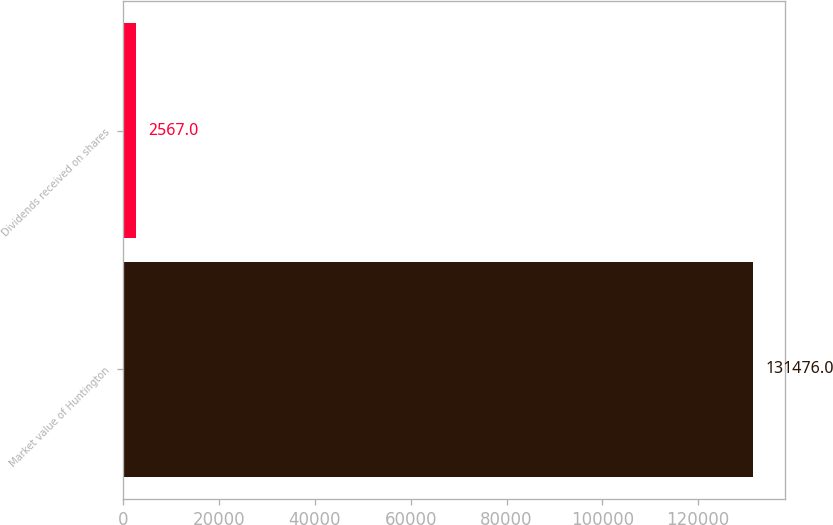Convert chart. <chart><loc_0><loc_0><loc_500><loc_500><bar_chart><fcel>Market value of Huntington<fcel>Dividends received on shares<nl><fcel>131476<fcel>2567<nl></chart> 